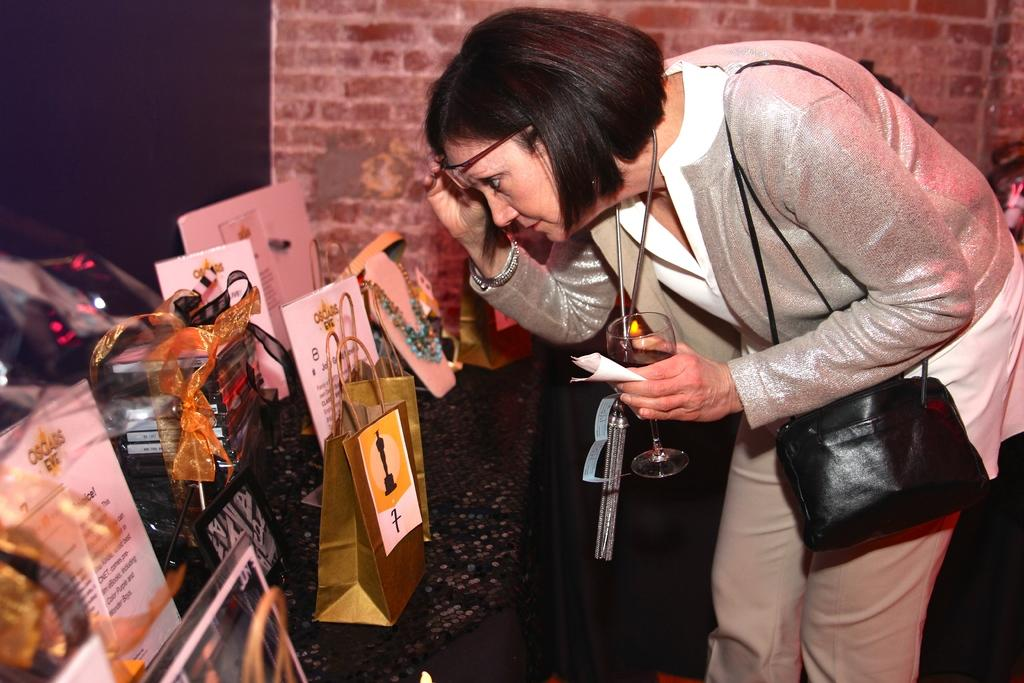Who is present in the image? There is a woman in the image. What is the woman doing in the image? The woman is standing in the image. What object is the woman holding in the image? The woman is holding a glass in the image. What accessory is the woman carrying in the image? The woman is carrying a handbag in the image. Are there any other handbags visible in the image? Yes, there are additional handbags visible in the image. What type of food is the woman eating in the image? There is no food visible in the image, and the woman is not shown eating. 